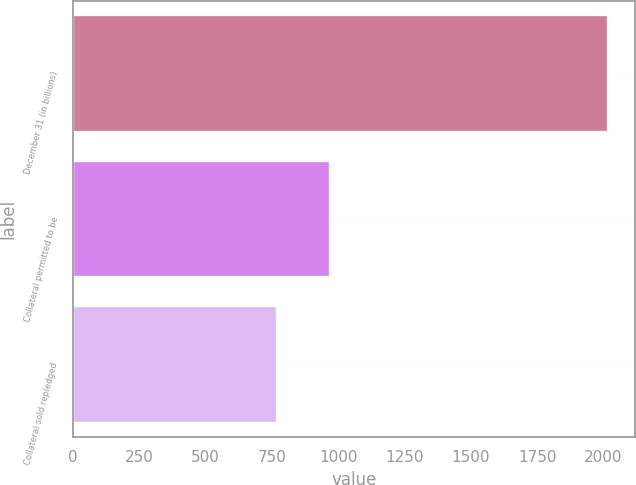<chart> <loc_0><loc_0><loc_500><loc_500><bar_chart><fcel>December 31 (in billions)<fcel>Collateral permitted to be<fcel>Collateral sold repledged<nl><fcel>2017<fcel>968.8<fcel>771<nl></chart> 